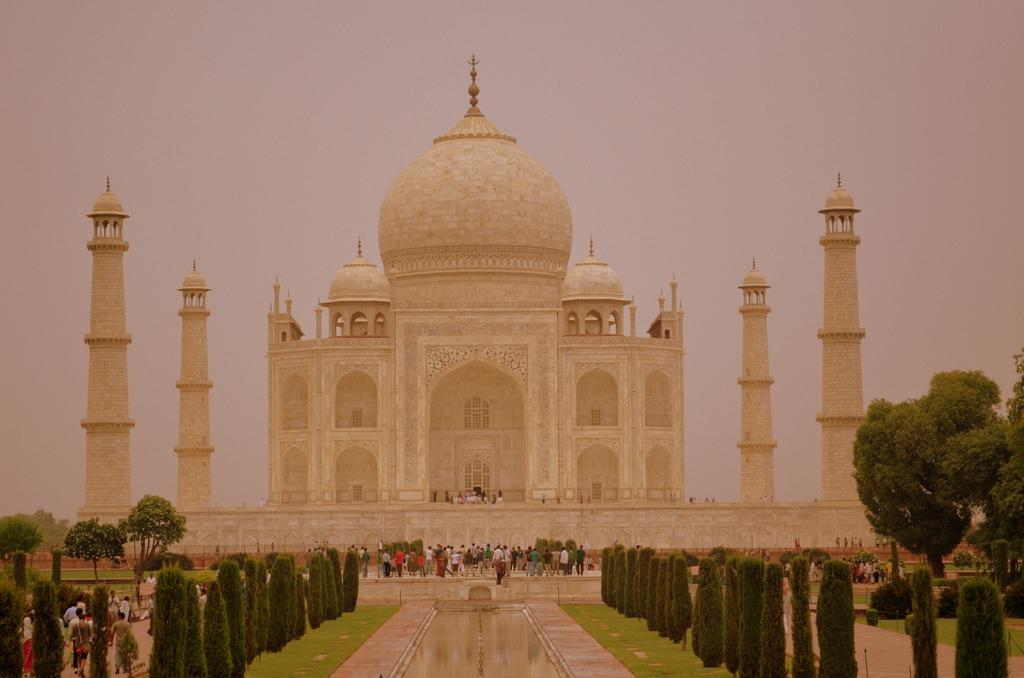What famous landmark is visible in the image? The Taj Mahal is present in the image. What are the people in the image doing? There are people walking in the image. What type of vegetation can be seen in the image? There are trees in the image. What body of water is present in the image? There is a pond in the image. What is the name of the tramp who is sitting by the sink in the image? There is no tramp or sink present in the image. 